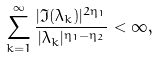<formula> <loc_0><loc_0><loc_500><loc_500>\sum _ { k = 1 } ^ { \infty } \frac { | \Im ( \lambda _ { k } ) | ^ { 2 \eta _ { 1 } } } { | \lambda _ { k } | ^ { \eta _ { 1 } - \eta _ { 2 } } } < \infty ,</formula> 